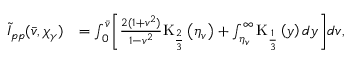Convert formula to latex. <formula><loc_0><loc_0><loc_500><loc_500>\begin{array} { r l } { \tilde { I } _ { p p } ( \bar { v } , \chi _ { \gamma } ) } & { = \int _ { 0 } ^ { \bar { v } } \left [ \frac { 2 ( 1 + v ^ { 2 } ) } { 1 - v ^ { 2 } } K _ { \frac { 2 } { 3 } } \left ( \eta _ { v } \right ) + \int _ { \eta _ { v } } ^ { \infty } K _ { \frac { 1 } { 3 } } \left ( y \right ) d y \right ] d v , } \end{array}</formula> 